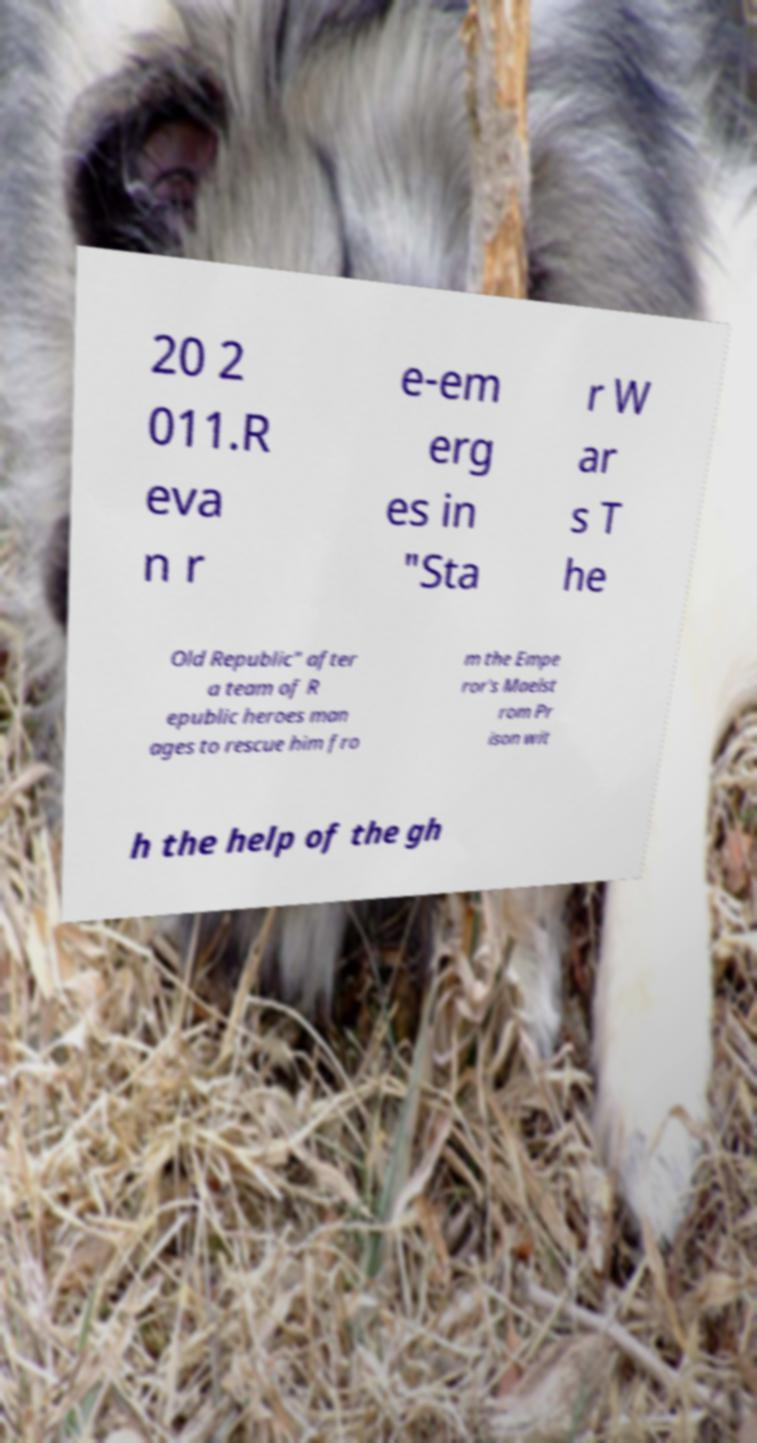Can you accurately transcribe the text from the provided image for me? 20 2 011.R eva n r e-em erg es in "Sta r W ar s T he Old Republic" after a team of R epublic heroes man ages to rescue him fro m the Empe ror's Maelst rom Pr ison wit h the help of the gh 